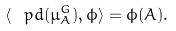<formula> <loc_0><loc_0><loc_500><loc_500>\langle \ p d ( \mu _ { A } ^ { G } ) , \phi \rangle = \phi ( A ) .</formula> 